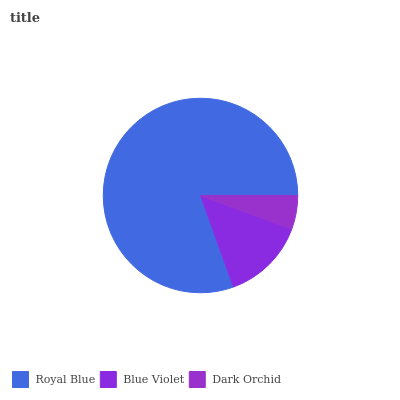Is Dark Orchid the minimum?
Answer yes or no. Yes. Is Royal Blue the maximum?
Answer yes or no. Yes. Is Blue Violet the minimum?
Answer yes or no. No. Is Blue Violet the maximum?
Answer yes or no. No. Is Royal Blue greater than Blue Violet?
Answer yes or no. Yes. Is Blue Violet less than Royal Blue?
Answer yes or no. Yes. Is Blue Violet greater than Royal Blue?
Answer yes or no. No. Is Royal Blue less than Blue Violet?
Answer yes or no. No. Is Blue Violet the high median?
Answer yes or no. Yes. Is Blue Violet the low median?
Answer yes or no. Yes. Is Dark Orchid the high median?
Answer yes or no. No. Is Royal Blue the low median?
Answer yes or no. No. 